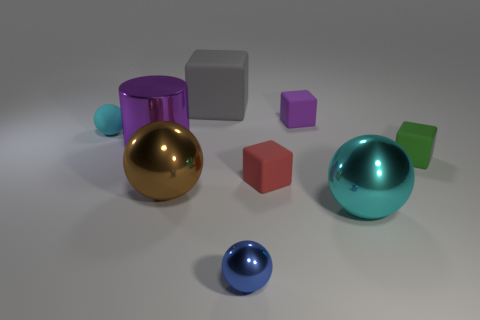Are there any patterns or colors that repeat in the objects? Yes, there are repeating colors among the objects. For example, the color blue is present in both a small sphere and in a cube. Although there aren't any discernible patterns like stripes or polka dots, the repetition of simple geometric shapes such as spheres and cubes creates a pattern of forms. 